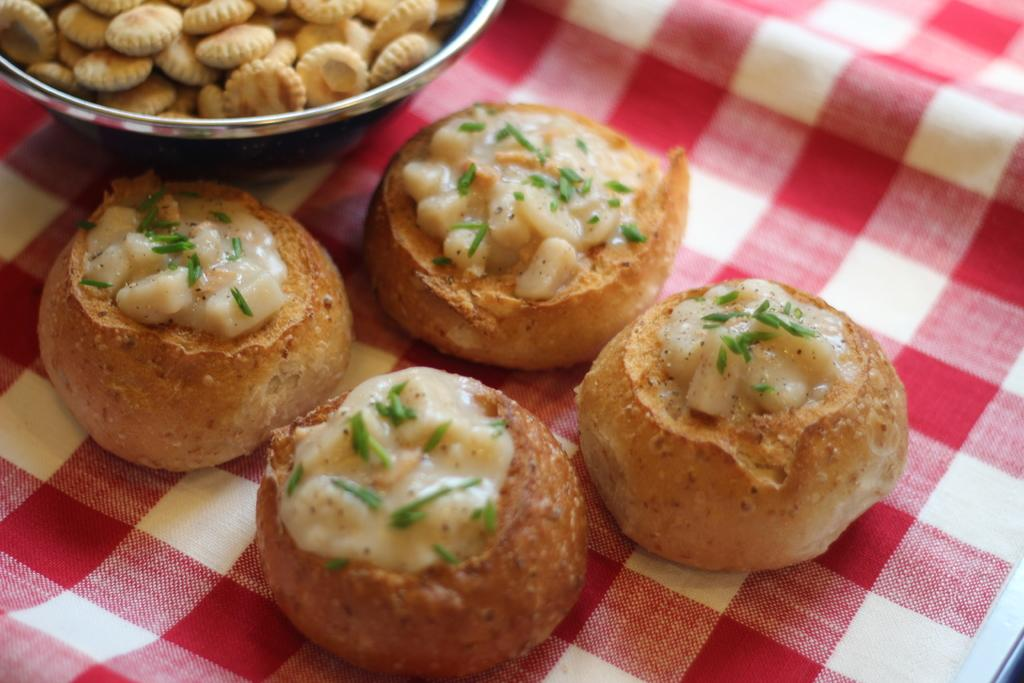What is the object containing food items in the image? The food items are in an object in the image, but the specific type of object is not mentioned. Where are some of the food items placed in the image? There are food items on a cloth in the image. What colors are present in the cloth? The cloth is red and white in color. How is the iron used to prepare the food items in the image? There is no iron present in the image, and therefore it cannot be used to prepare the food items. 